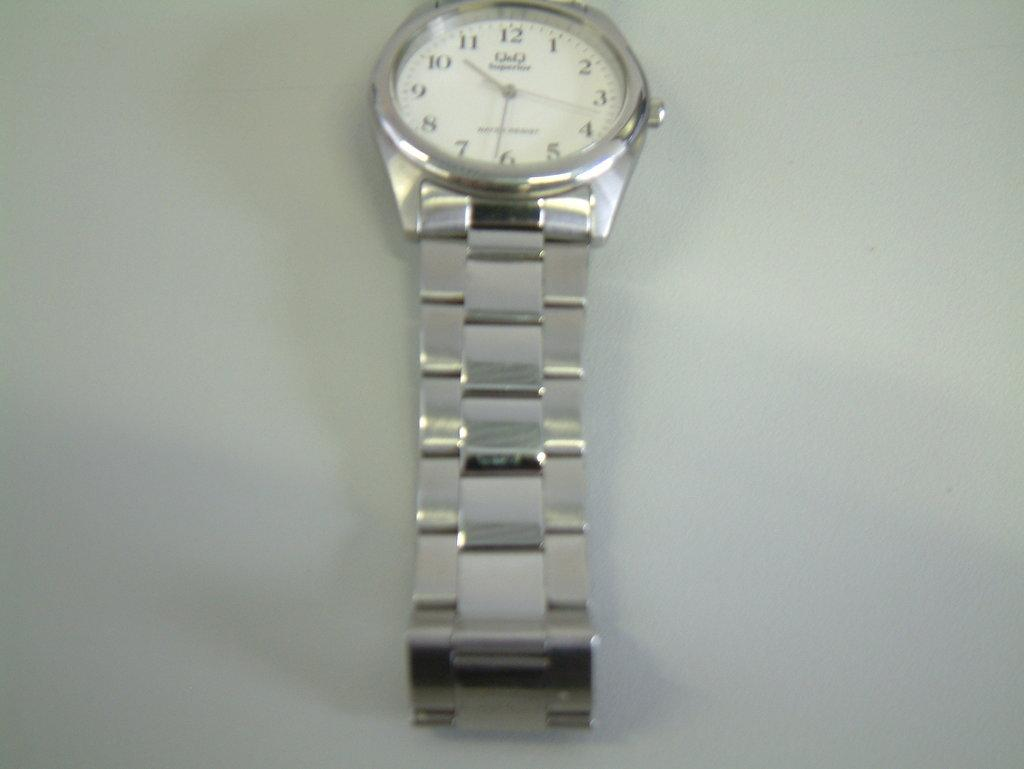<image>
Describe the image concisely. the numbers 12 to 1 on a watch that is silver 